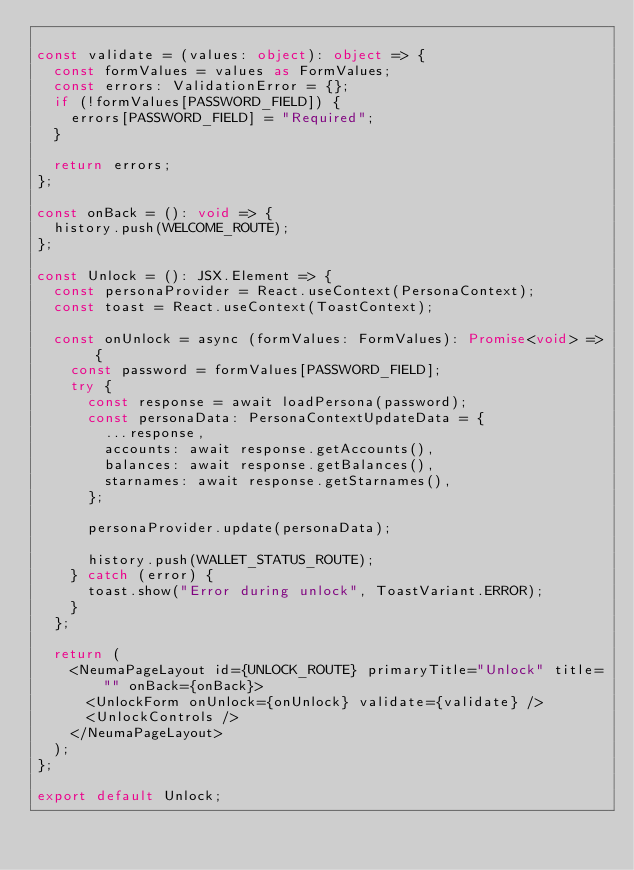Convert code to text. <code><loc_0><loc_0><loc_500><loc_500><_TypeScript_>
const validate = (values: object): object => {
  const formValues = values as FormValues;
  const errors: ValidationError = {};
  if (!formValues[PASSWORD_FIELD]) {
    errors[PASSWORD_FIELD] = "Required";
  }

  return errors;
};

const onBack = (): void => {
  history.push(WELCOME_ROUTE);
};

const Unlock = (): JSX.Element => {
  const personaProvider = React.useContext(PersonaContext);
  const toast = React.useContext(ToastContext);

  const onUnlock = async (formValues: FormValues): Promise<void> => {
    const password = formValues[PASSWORD_FIELD];
    try {
      const response = await loadPersona(password);
      const personaData: PersonaContextUpdateData = {
        ...response,
        accounts: await response.getAccounts(),
        balances: await response.getBalances(),
        starnames: await response.getStarnames(),
      };

      personaProvider.update(personaData);

      history.push(WALLET_STATUS_ROUTE);
    } catch (error) {
      toast.show("Error during unlock", ToastVariant.ERROR);
    }
  };

  return (
    <NeumaPageLayout id={UNLOCK_ROUTE} primaryTitle="Unlock" title="" onBack={onBack}>
      <UnlockForm onUnlock={onUnlock} validate={validate} />
      <UnlockControls />
    </NeumaPageLayout>
  );
};

export default Unlock;
</code> 